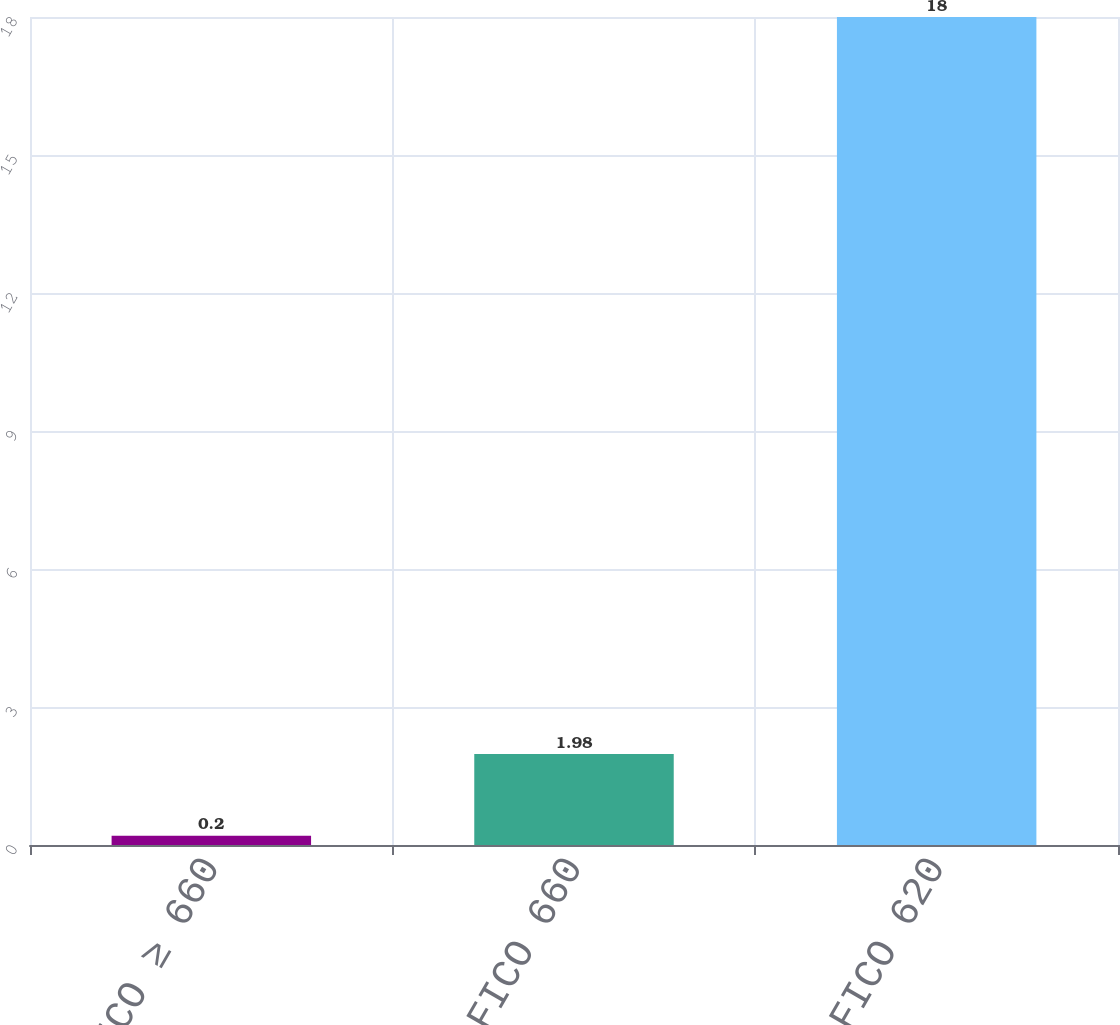<chart> <loc_0><loc_0><loc_500><loc_500><bar_chart><fcel>FICO ≥ 660<fcel>620 ≤ FICO 660<fcel>FICO 620<nl><fcel>0.2<fcel>1.98<fcel>18<nl></chart> 